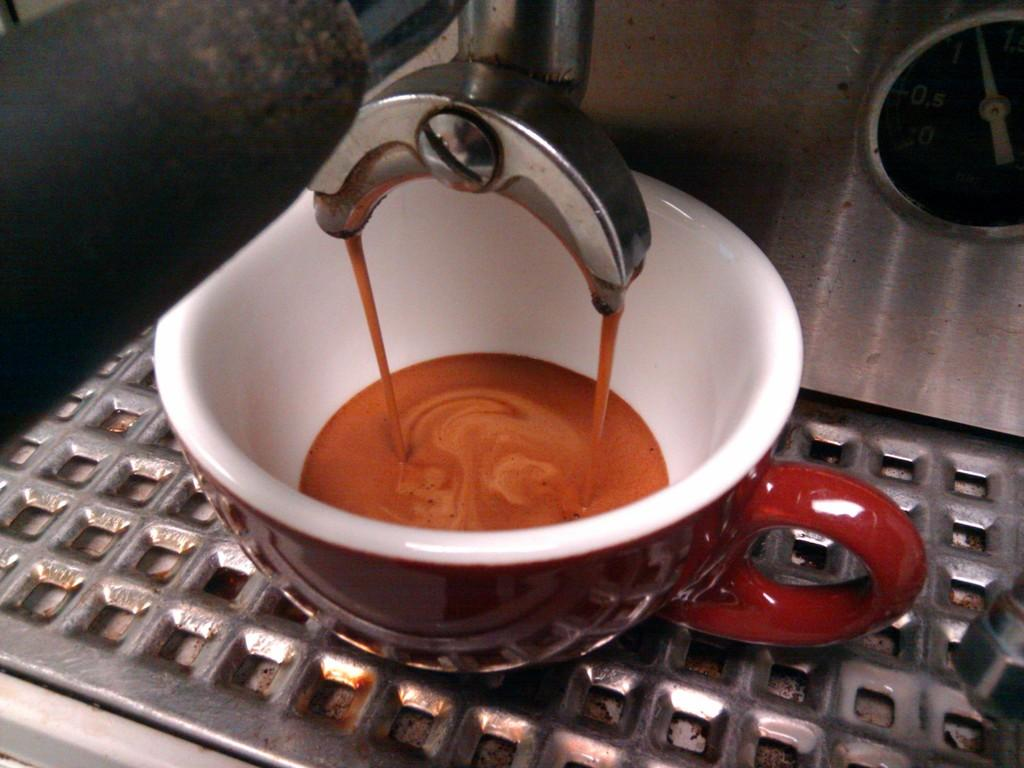What is the main object in the image? There is a machine in the image. What else can be seen in the image besides the machine? There is a cup with a drink in the image. What are the colors of the cup? The cup is maroon and white in color. What is the color of the drink in the cup? The drink in the cup is brown in color. What is the material of the surface the cup is on? The surface the cup is on is made of steel. Can you tell me how many breaths the machine takes in the image? The machine in the image does not take breaths, as it is not a living organism. What type of meal is being prepared in the image? There is no meal being prepared in the image; it only shows a machine, a cup with a drink, and a steel surface. 